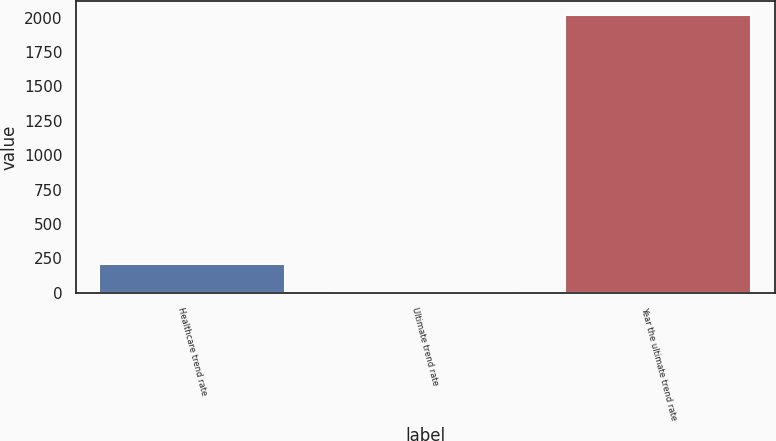<chart> <loc_0><loc_0><loc_500><loc_500><bar_chart><fcel>Healthcare trend rate<fcel>Ultimate trend rate<fcel>Year the ultimate trend rate<nl><fcel>206.4<fcel>5<fcel>2019<nl></chart> 